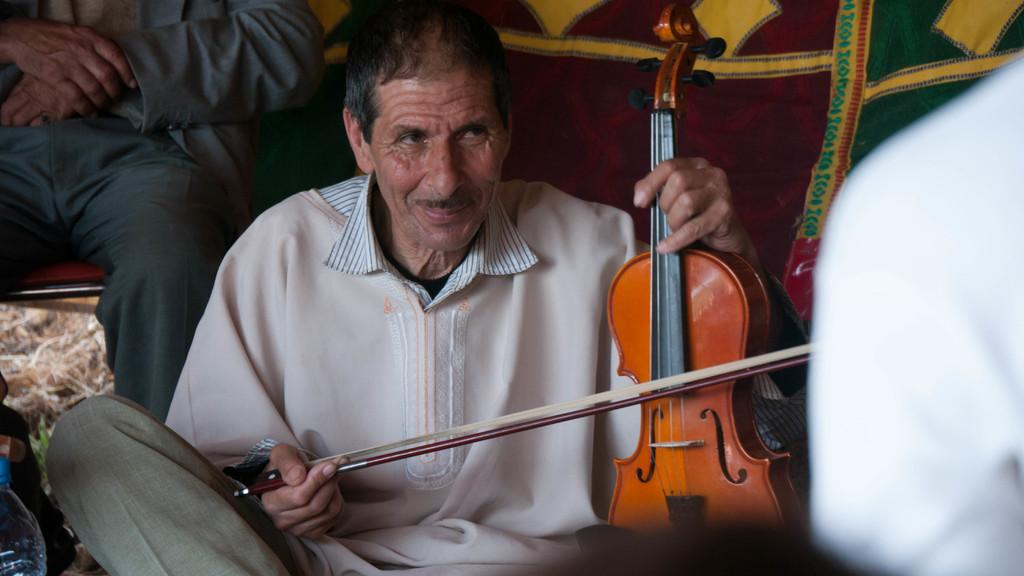Who is present in the image? There is a man in the image. What is the man doing in the image? The man is sitting on the floor. What is the man holding in the image? The man is holding a musical instrument. What type of stick is the man using to play the musical instrument in the image? There is no stick present in the image; the man is holding a musical instrument, but no specific type of stick is mentioned or visible. 